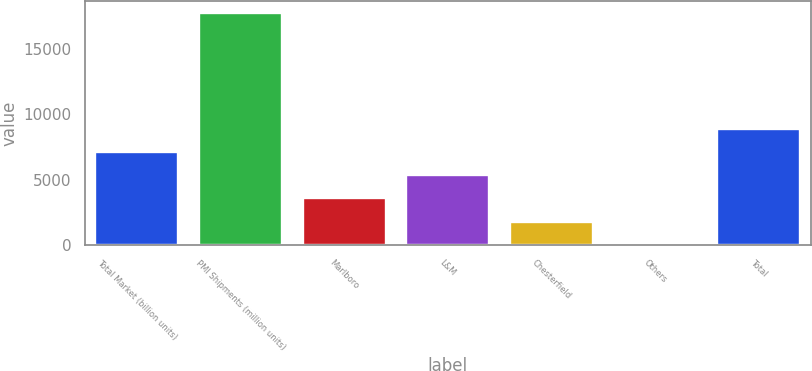<chart> <loc_0><loc_0><loc_500><loc_500><bar_chart><fcel>Total Market (billion units)<fcel>PMI Shipments (million units)<fcel>Marlboro<fcel>L&M<fcel>Chesterfield<fcel>Others<fcel>Total<nl><fcel>7115.4<fcel>17784<fcel>3559.2<fcel>5337.3<fcel>1781.1<fcel>3<fcel>8893.5<nl></chart> 